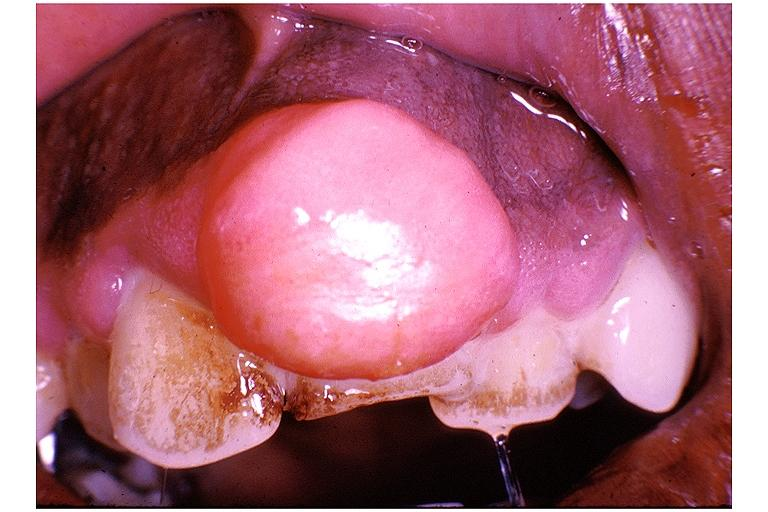s side present?
Answer the question using a single word or phrase. No 